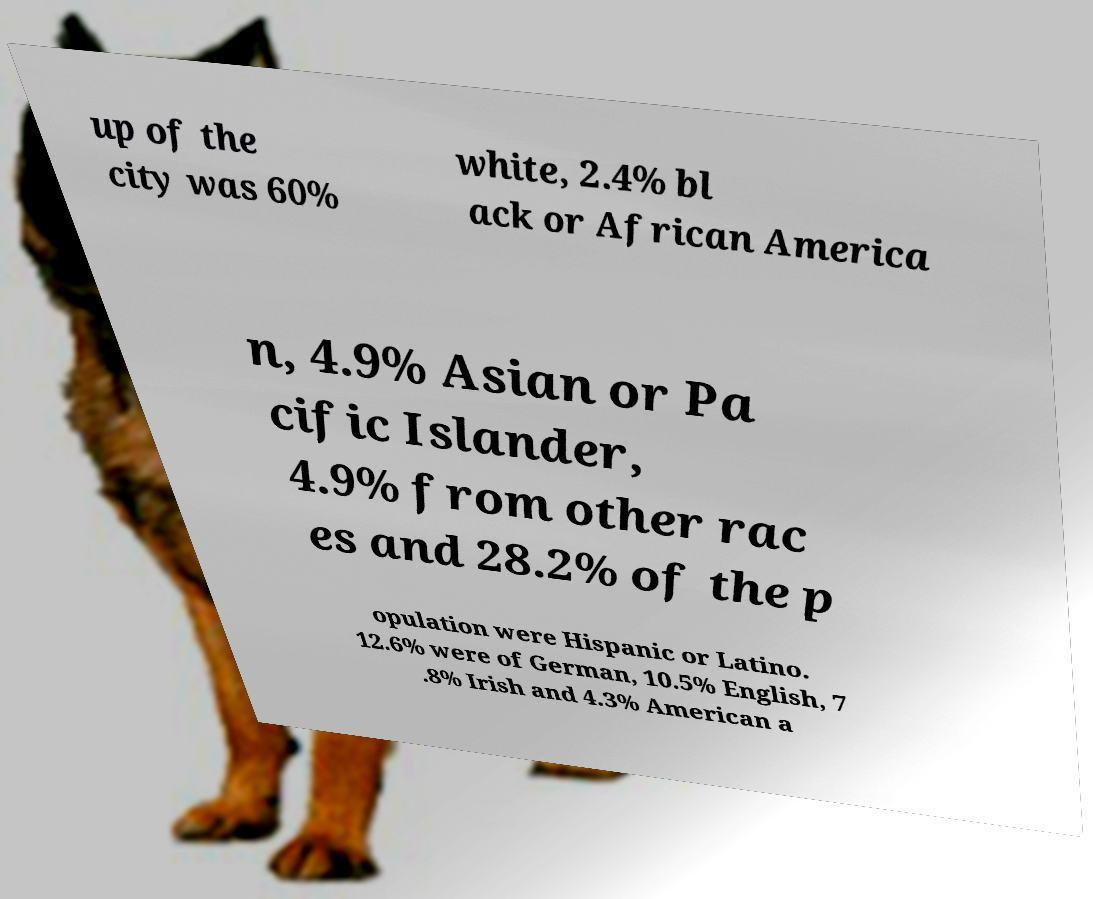Please identify and transcribe the text found in this image. up of the city was 60% white, 2.4% bl ack or African America n, 4.9% Asian or Pa cific Islander, 4.9% from other rac es and 28.2% of the p opulation were Hispanic or Latino. 12.6% were of German, 10.5% English, 7 .8% Irish and 4.3% American a 